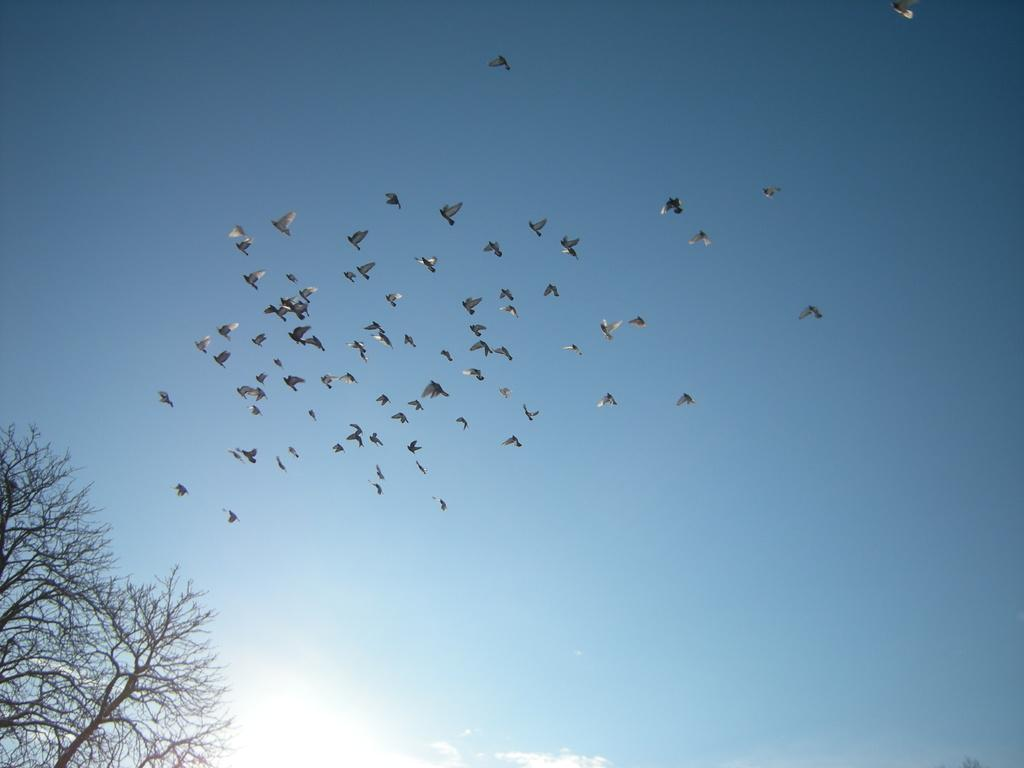What is happening in the sky in the image? There are birds flying in the sky in the image. What can be seen on the left side of the image? There is a tree on the left side of the image. What type of lift can be seen in the image? There is no lift present in the image; it features birds flying in the sky and a tree on the left side. What advice does the father give in the image? There is no father present in the image, nor any indication of advice being given. 